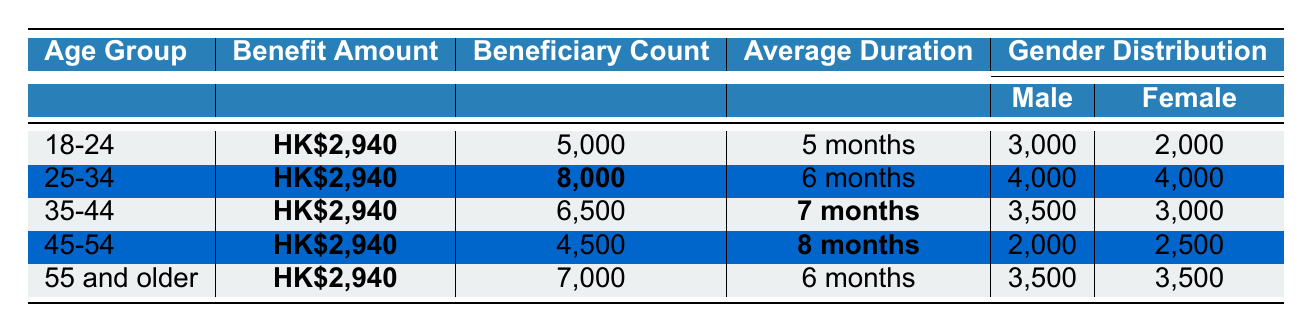What is the benefit amount for all age groups? The table shows that the benefit amount for each age group is consistently **HK$2,940**.
Answer: HK$2,940 How many beneficiaries are in the 25-34 age group? The beneficiary count for the 25-34 age group is highlighted as **8,000** in the table.
Answer: 8,000 What is the average duration of benefits for the 45-54 age group? The average duration of benefits for the 45-54 age group is stated as **8 months** in the table.
Answer: 8 months Which age group has the highest number of beneficiaries? Comparing the beneficiary counts, the 25-34 age group has **8,000** beneficiaries, which is higher than any other age group.
Answer: 25-34 How many male beneficiaries are there in the 18-24 age group? The number of male beneficiaries in the 18-24 age group is **3,000** according to the gender distribution in the table.
Answer: 3,000 What is the total number of female beneficiaries across all age groups? Adding the female beneficiaries in each age group: 2,000 (18-24) + 4,000 (25-34) + 3,000 (35-44) + 2,500 (45-54) + 3,500 (55 and older) = 15,000.
Answer: 15,000 Is the average duration of benefits for the 35-44 age group less than for the 55 and older group? The average duration for the 35-44 age group is **7 months**, while for the 55 and older group, it is **6 months**; therefore, the average for 35-44 is greater.
Answer: No How many more beneficiaries are there in the 25-34 age group compared to the 45-54 age group? The difference is calculated as 8,000 (25-34) - 4,500 (45-54) = 3,500 more beneficiaries in the 25-34 age group.
Answer: 3,500 What percentage of male beneficiaries does the 18-24 age group represent of the total male beneficiaries across all groups? The total male beneficiaries across all groups is 3,000 (18-24) + 4,000 (25-34) + 3,500 (35-44) + 2,000 (45-54) + 3,500 (55 and older) = 16,000. The percentage is (3,000 / 16,000) * 100 = 18.75%.
Answer: 18.75% Which age group has the least number of beneficiaries, and how many are they? The 45-54 age group has the least number of beneficiaries with just **4,500** individuals.
Answer: 45-54, 4,500 